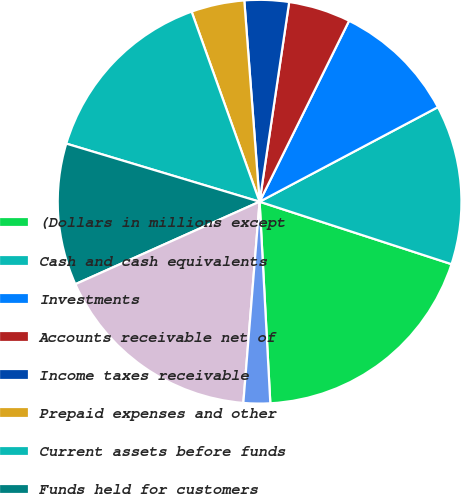Convert chart to OTSL. <chart><loc_0><loc_0><loc_500><loc_500><pie_chart><fcel>(Dollars in millions except<fcel>Cash and cash equivalents<fcel>Investments<fcel>Accounts receivable net of<fcel>Income taxes receivable<fcel>Prepaid expenses and other<fcel>Current assets before funds<fcel>Funds held for customers<fcel>Total current assets<fcel>Long-term investments<nl><fcel>19.15%<fcel>12.77%<fcel>9.93%<fcel>4.97%<fcel>3.55%<fcel>4.26%<fcel>14.89%<fcel>11.35%<fcel>17.02%<fcel>2.13%<nl></chart> 